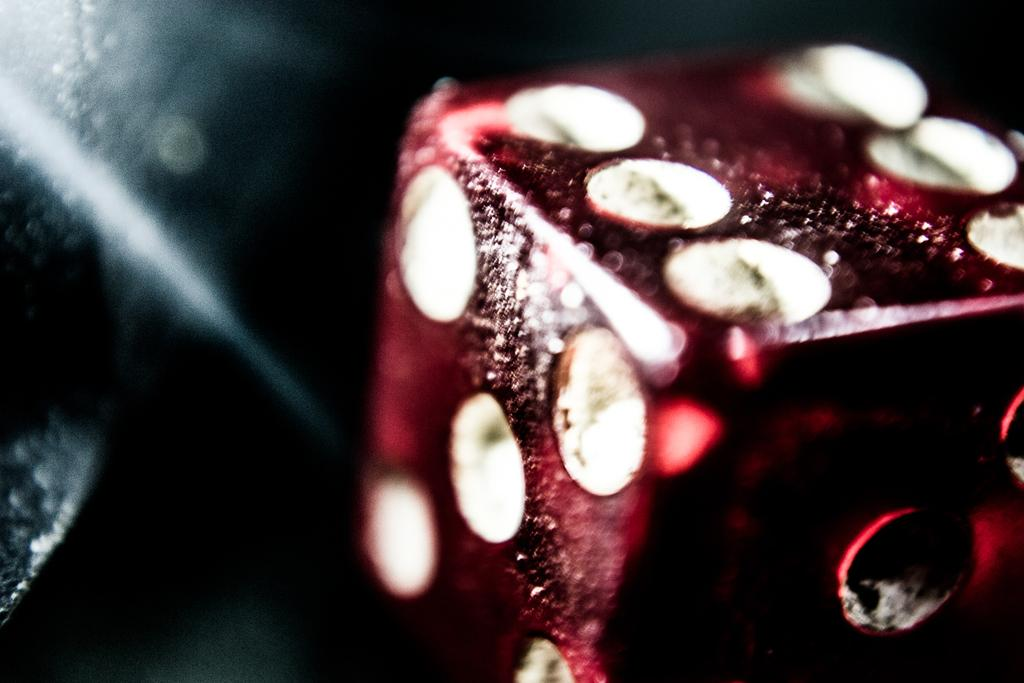What object is the main subject of the image? There is a dice in the image. What colors are present on the dice? The dice is maroon and white in color. Can you describe the background of the image? The background of the image is dark. What type of pest can be seen crawling on the dice in the image? There is no pest present on the dice in the image. What song is being played in the background of the image? There is no song playing in the image, as it is a still image and not a video or audio recording. 